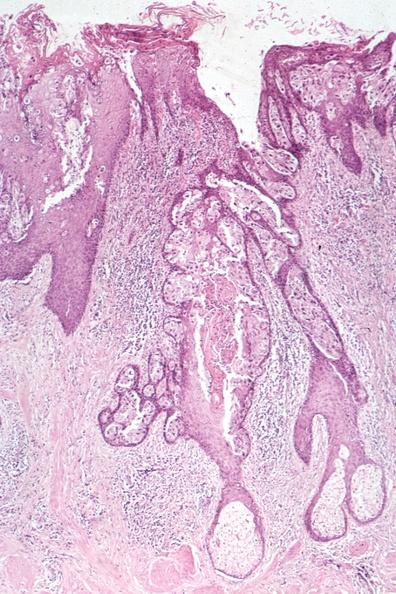s this image a quite good example of pagets disease?
Answer the question using a single word or phrase. Yes 